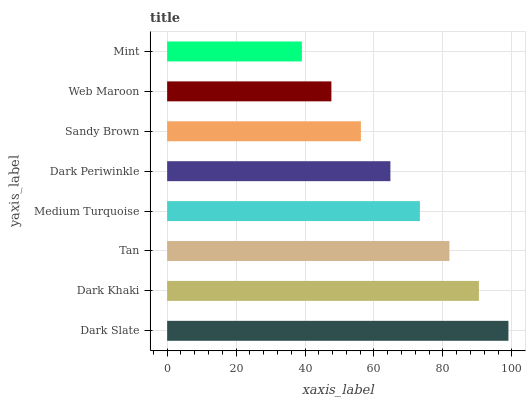Is Mint the minimum?
Answer yes or no. Yes. Is Dark Slate the maximum?
Answer yes or no. Yes. Is Dark Khaki the minimum?
Answer yes or no. No. Is Dark Khaki the maximum?
Answer yes or no. No. Is Dark Slate greater than Dark Khaki?
Answer yes or no. Yes. Is Dark Khaki less than Dark Slate?
Answer yes or no. Yes. Is Dark Khaki greater than Dark Slate?
Answer yes or no. No. Is Dark Slate less than Dark Khaki?
Answer yes or no. No. Is Medium Turquoise the high median?
Answer yes or no. Yes. Is Dark Periwinkle the low median?
Answer yes or no. Yes. Is Tan the high median?
Answer yes or no. No. Is Medium Turquoise the low median?
Answer yes or no. No. 